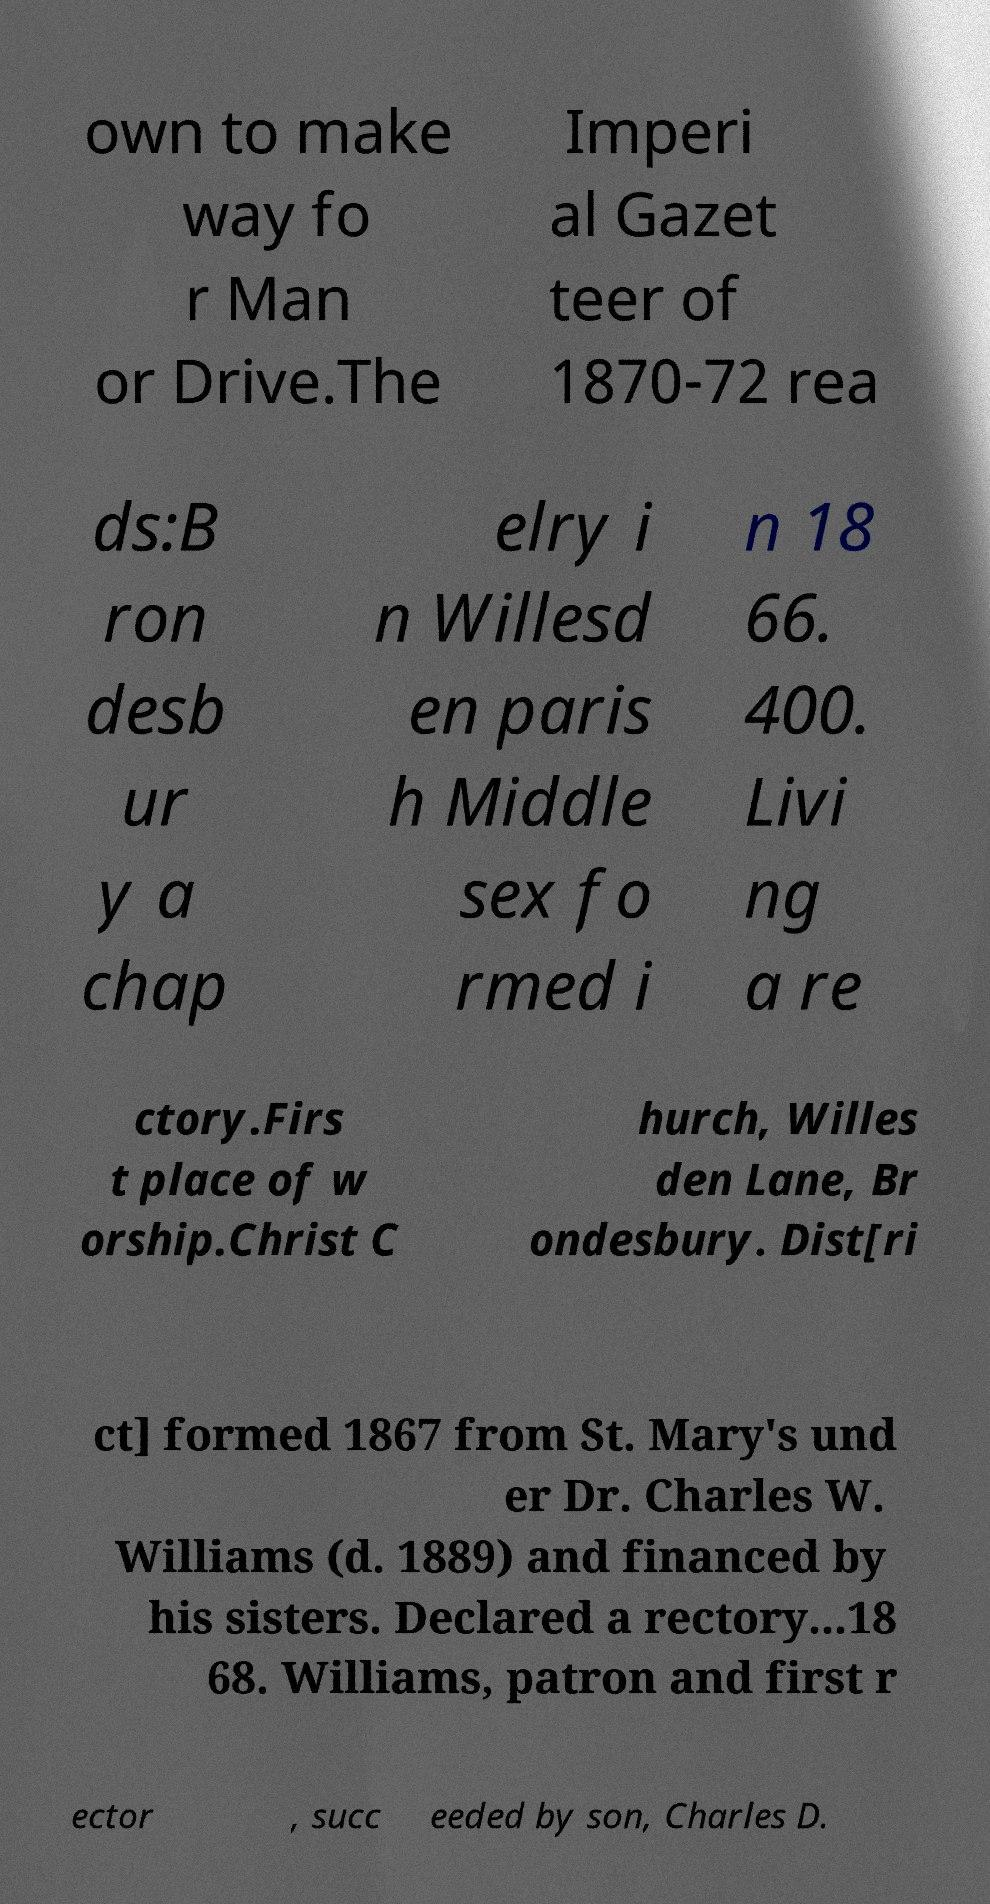I need the written content from this picture converted into text. Can you do that? own to make way fo r Man or Drive.The Imperi al Gazet teer of 1870-72 rea ds:B ron desb ur y a chap elry i n Willesd en paris h Middle sex fo rmed i n 18 66. 400. Livi ng a re ctory.Firs t place of w orship.Christ C hurch, Willes den Lane, Br ondesbury. Dist[ri ct] formed 1867 from St. Mary's und er Dr. Charles W. Williams (d. 1889) and financed by his sisters. Declared a rectory...18 68. Williams, patron and first r ector , succ eeded by son, Charles D. 